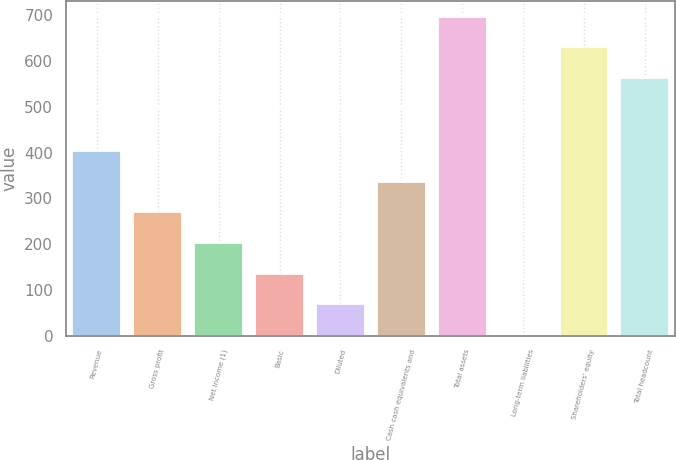<chart> <loc_0><loc_0><loc_500><loc_500><bar_chart><fcel>Revenue<fcel>Gross profit<fcel>Net income (1)<fcel>Basic<fcel>Diluted<fcel>Cash cash equivalents and<fcel>Total assets<fcel>Long-term liabilities<fcel>Shareholders' equity<fcel>Total headcount<nl><fcel>403.64<fcel>269.56<fcel>202.52<fcel>135.48<fcel>68.44<fcel>336.6<fcel>697.08<fcel>1.4<fcel>630.04<fcel>563<nl></chart> 